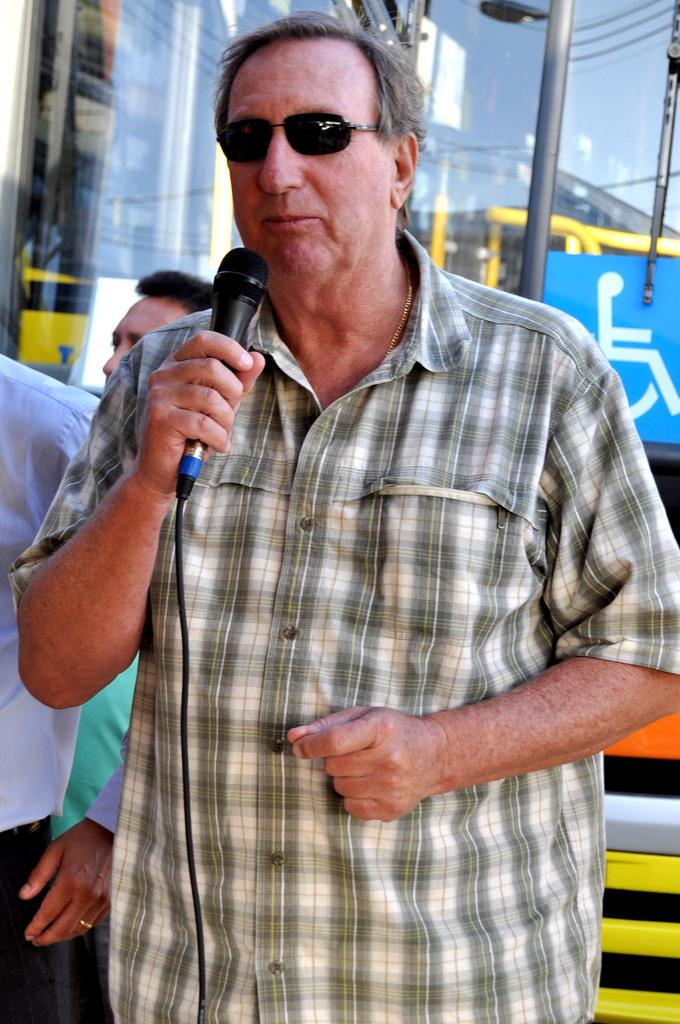What is the man in the image doing? The man is standing in the image and holding a microphone. What is the man wearing in the image? The man is wearing a checkered shirt in the image. What can be seen in the background of the image? There is a vehicle, a pole, and people standing in the background of the image. What type of pear is hanging from the pole in the image? There is no pear present in the image, and no fruit is hanging from the pole. How many thumbs does the man have on his right hand in the image? The number of thumbs on the man's right hand cannot be determined from the image, as it is not visible. 